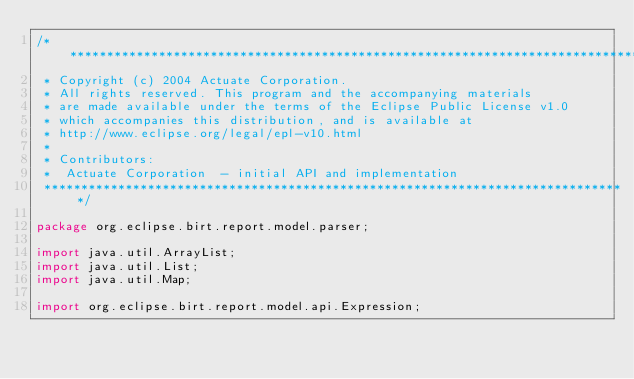<code> <loc_0><loc_0><loc_500><loc_500><_Java_>/*******************************************************************************
 * Copyright (c) 2004 Actuate Corporation.
 * All rights reserved. This program and the accompanying materials
 * are made available under the terms of the Eclipse Public License v1.0
 * which accompanies this distribution, and is available at
 * http://www.eclipse.org/legal/epl-v10.html
 *
 * Contributors:
 *  Actuate Corporation  - initial API and implementation
 *******************************************************************************/

package org.eclipse.birt.report.model.parser;

import java.util.ArrayList;
import java.util.List;
import java.util.Map;

import org.eclipse.birt.report.model.api.Expression;</code> 